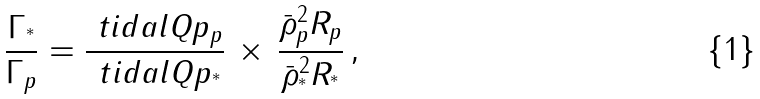Convert formula to latex. <formula><loc_0><loc_0><loc_500><loc_500>\frac { \Gamma _ { ^ { * } } } { \Gamma _ { p } } = \frac { \ t i d a l Q p _ { p } } { \ t i d a l Q p _ { ^ { * } } } \, \times \, \frac { \bar { \rho } _ { p } ^ { 2 } R _ { p } } { \bar { \rho } _ { ^ { * } } ^ { 2 } R _ { ^ { * } } } \, ,</formula> 